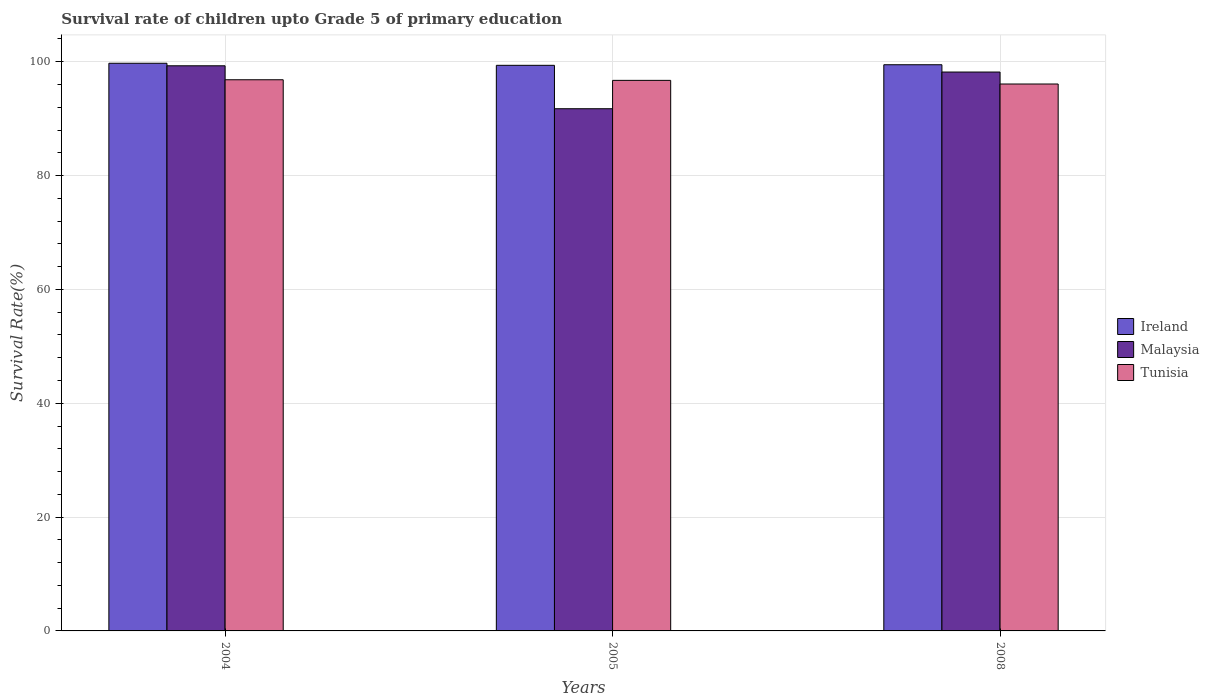What is the label of the 3rd group of bars from the left?
Provide a short and direct response. 2008. In how many cases, is the number of bars for a given year not equal to the number of legend labels?
Offer a terse response. 0. What is the survival rate of children in Malaysia in 2008?
Your answer should be very brief. 98.19. Across all years, what is the maximum survival rate of children in Malaysia?
Offer a terse response. 99.29. Across all years, what is the minimum survival rate of children in Tunisia?
Provide a short and direct response. 96.09. In which year was the survival rate of children in Ireland maximum?
Make the answer very short. 2004. What is the total survival rate of children in Malaysia in the graph?
Your answer should be compact. 289.23. What is the difference between the survival rate of children in Tunisia in 2004 and that in 2005?
Keep it short and to the point. 0.11. What is the difference between the survival rate of children in Ireland in 2008 and the survival rate of children in Malaysia in 2004?
Offer a terse response. 0.18. What is the average survival rate of children in Ireland per year?
Make the answer very short. 99.53. In the year 2008, what is the difference between the survival rate of children in Tunisia and survival rate of children in Ireland?
Offer a terse response. -3.39. What is the ratio of the survival rate of children in Malaysia in 2005 to that in 2008?
Give a very brief answer. 0.93. Is the survival rate of children in Malaysia in 2005 less than that in 2008?
Provide a short and direct response. Yes. What is the difference between the highest and the second highest survival rate of children in Ireland?
Keep it short and to the point. 0.26. What is the difference between the highest and the lowest survival rate of children in Tunisia?
Your answer should be very brief. 0.75. In how many years, is the survival rate of children in Malaysia greater than the average survival rate of children in Malaysia taken over all years?
Make the answer very short. 2. What does the 3rd bar from the left in 2008 represents?
Provide a succinct answer. Tunisia. What does the 2nd bar from the right in 2008 represents?
Provide a succinct answer. Malaysia. Is it the case that in every year, the sum of the survival rate of children in Tunisia and survival rate of children in Ireland is greater than the survival rate of children in Malaysia?
Offer a very short reply. Yes. Are all the bars in the graph horizontal?
Keep it short and to the point. No. How many years are there in the graph?
Give a very brief answer. 3. Does the graph contain any zero values?
Give a very brief answer. No. Does the graph contain grids?
Keep it short and to the point. Yes. What is the title of the graph?
Make the answer very short. Survival rate of children upto Grade 5 of primary education. Does "Belarus" appear as one of the legend labels in the graph?
Provide a short and direct response. No. What is the label or title of the Y-axis?
Make the answer very short. Survival Rate(%). What is the Survival Rate(%) in Ireland in 2004?
Provide a succinct answer. 99.74. What is the Survival Rate(%) in Malaysia in 2004?
Offer a terse response. 99.29. What is the Survival Rate(%) of Tunisia in 2004?
Ensure brevity in your answer.  96.84. What is the Survival Rate(%) in Ireland in 2005?
Make the answer very short. 99.37. What is the Survival Rate(%) in Malaysia in 2005?
Your answer should be compact. 91.75. What is the Survival Rate(%) in Tunisia in 2005?
Your answer should be very brief. 96.73. What is the Survival Rate(%) of Ireland in 2008?
Ensure brevity in your answer.  99.48. What is the Survival Rate(%) in Malaysia in 2008?
Ensure brevity in your answer.  98.19. What is the Survival Rate(%) in Tunisia in 2008?
Your answer should be compact. 96.09. Across all years, what is the maximum Survival Rate(%) of Ireland?
Offer a very short reply. 99.74. Across all years, what is the maximum Survival Rate(%) in Malaysia?
Your response must be concise. 99.29. Across all years, what is the maximum Survival Rate(%) of Tunisia?
Your response must be concise. 96.84. Across all years, what is the minimum Survival Rate(%) of Ireland?
Provide a short and direct response. 99.37. Across all years, what is the minimum Survival Rate(%) of Malaysia?
Provide a succinct answer. 91.75. Across all years, what is the minimum Survival Rate(%) in Tunisia?
Make the answer very short. 96.09. What is the total Survival Rate(%) of Ireland in the graph?
Give a very brief answer. 298.59. What is the total Survival Rate(%) of Malaysia in the graph?
Offer a terse response. 289.23. What is the total Survival Rate(%) in Tunisia in the graph?
Offer a very short reply. 289.65. What is the difference between the Survival Rate(%) in Ireland in 2004 and that in 2005?
Keep it short and to the point. 0.36. What is the difference between the Survival Rate(%) of Malaysia in 2004 and that in 2005?
Offer a very short reply. 7.54. What is the difference between the Survival Rate(%) of Tunisia in 2004 and that in 2005?
Your answer should be very brief. 0.11. What is the difference between the Survival Rate(%) in Ireland in 2004 and that in 2008?
Make the answer very short. 0.26. What is the difference between the Survival Rate(%) in Malaysia in 2004 and that in 2008?
Keep it short and to the point. 1.1. What is the difference between the Survival Rate(%) of Tunisia in 2004 and that in 2008?
Give a very brief answer. 0.75. What is the difference between the Survival Rate(%) in Ireland in 2005 and that in 2008?
Give a very brief answer. -0.1. What is the difference between the Survival Rate(%) in Malaysia in 2005 and that in 2008?
Provide a short and direct response. -6.45. What is the difference between the Survival Rate(%) in Tunisia in 2005 and that in 2008?
Your answer should be compact. 0.64. What is the difference between the Survival Rate(%) in Ireland in 2004 and the Survival Rate(%) in Malaysia in 2005?
Make the answer very short. 7.99. What is the difference between the Survival Rate(%) in Ireland in 2004 and the Survival Rate(%) in Tunisia in 2005?
Provide a short and direct response. 3.01. What is the difference between the Survival Rate(%) in Malaysia in 2004 and the Survival Rate(%) in Tunisia in 2005?
Make the answer very short. 2.56. What is the difference between the Survival Rate(%) of Ireland in 2004 and the Survival Rate(%) of Malaysia in 2008?
Ensure brevity in your answer.  1.54. What is the difference between the Survival Rate(%) in Ireland in 2004 and the Survival Rate(%) in Tunisia in 2008?
Offer a very short reply. 3.65. What is the difference between the Survival Rate(%) in Malaysia in 2004 and the Survival Rate(%) in Tunisia in 2008?
Make the answer very short. 3.2. What is the difference between the Survival Rate(%) in Ireland in 2005 and the Survival Rate(%) in Malaysia in 2008?
Make the answer very short. 1.18. What is the difference between the Survival Rate(%) of Ireland in 2005 and the Survival Rate(%) of Tunisia in 2008?
Ensure brevity in your answer.  3.28. What is the difference between the Survival Rate(%) of Malaysia in 2005 and the Survival Rate(%) of Tunisia in 2008?
Make the answer very short. -4.34. What is the average Survival Rate(%) of Ireland per year?
Provide a succinct answer. 99.53. What is the average Survival Rate(%) in Malaysia per year?
Your response must be concise. 96.41. What is the average Survival Rate(%) of Tunisia per year?
Provide a short and direct response. 96.55. In the year 2004, what is the difference between the Survival Rate(%) of Ireland and Survival Rate(%) of Malaysia?
Keep it short and to the point. 0.44. In the year 2004, what is the difference between the Survival Rate(%) of Ireland and Survival Rate(%) of Tunisia?
Your response must be concise. 2.9. In the year 2004, what is the difference between the Survival Rate(%) in Malaysia and Survival Rate(%) in Tunisia?
Keep it short and to the point. 2.46. In the year 2005, what is the difference between the Survival Rate(%) in Ireland and Survival Rate(%) in Malaysia?
Provide a short and direct response. 7.63. In the year 2005, what is the difference between the Survival Rate(%) in Ireland and Survival Rate(%) in Tunisia?
Your answer should be compact. 2.65. In the year 2005, what is the difference between the Survival Rate(%) of Malaysia and Survival Rate(%) of Tunisia?
Provide a short and direct response. -4.98. In the year 2008, what is the difference between the Survival Rate(%) in Ireland and Survival Rate(%) in Malaysia?
Offer a very short reply. 1.28. In the year 2008, what is the difference between the Survival Rate(%) in Ireland and Survival Rate(%) in Tunisia?
Give a very brief answer. 3.39. In the year 2008, what is the difference between the Survival Rate(%) in Malaysia and Survival Rate(%) in Tunisia?
Make the answer very short. 2.1. What is the ratio of the Survival Rate(%) in Ireland in 2004 to that in 2005?
Ensure brevity in your answer.  1. What is the ratio of the Survival Rate(%) in Malaysia in 2004 to that in 2005?
Provide a succinct answer. 1.08. What is the ratio of the Survival Rate(%) in Malaysia in 2004 to that in 2008?
Your response must be concise. 1.01. What is the ratio of the Survival Rate(%) of Tunisia in 2004 to that in 2008?
Keep it short and to the point. 1.01. What is the ratio of the Survival Rate(%) in Ireland in 2005 to that in 2008?
Provide a short and direct response. 1. What is the ratio of the Survival Rate(%) in Malaysia in 2005 to that in 2008?
Provide a succinct answer. 0.93. What is the ratio of the Survival Rate(%) in Tunisia in 2005 to that in 2008?
Provide a short and direct response. 1.01. What is the difference between the highest and the second highest Survival Rate(%) of Ireland?
Give a very brief answer. 0.26. What is the difference between the highest and the second highest Survival Rate(%) of Malaysia?
Provide a succinct answer. 1.1. What is the difference between the highest and the second highest Survival Rate(%) in Tunisia?
Your response must be concise. 0.11. What is the difference between the highest and the lowest Survival Rate(%) in Ireland?
Your answer should be very brief. 0.36. What is the difference between the highest and the lowest Survival Rate(%) in Malaysia?
Offer a very short reply. 7.54. What is the difference between the highest and the lowest Survival Rate(%) of Tunisia?
Offer a very short reply. 0.75. 